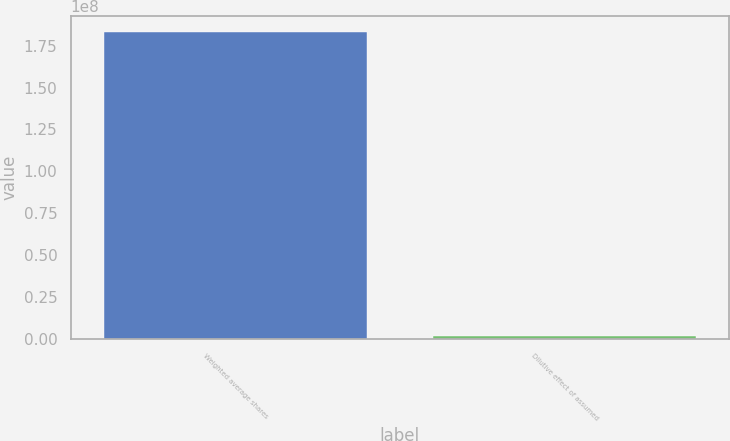Convert chart. <chart><loc_0><loc_0><loc_500><loc_500><bar_chart><fcel>Weighted average shares<fcel>Dilutive effect of assumed<nl><fcel>1.83361e+08<fcel>2.15e+06<nl></chart> 